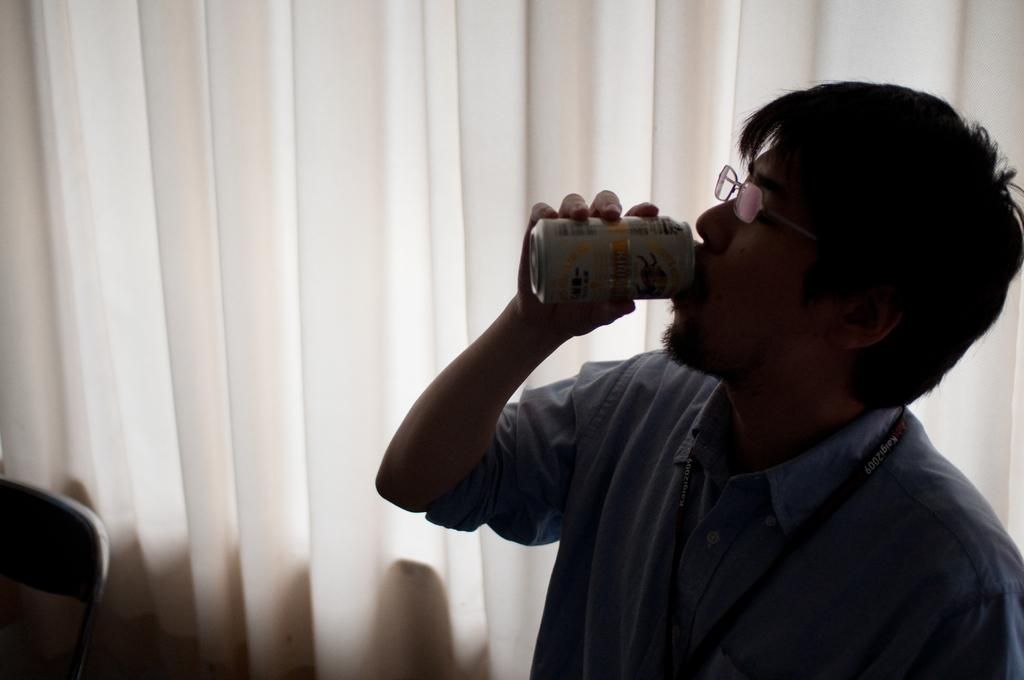Who is present in the image on the right side? There is a person on the right side of the image. What is the person holding in the image? The person is holding a tin. What piece of furniture can be seen at the bottom left corner of the image? There is a chair at the bottom left corner of the image. What can be seen in the background of the image? There is a curtain in the background of the image. What type of collar is the person wearing in the image? There is no collar visible on the person in the image. What scene is taking place in the image? The image does not depict a scene; it is a snapshot of a person holding a tin and a chair in the background. 